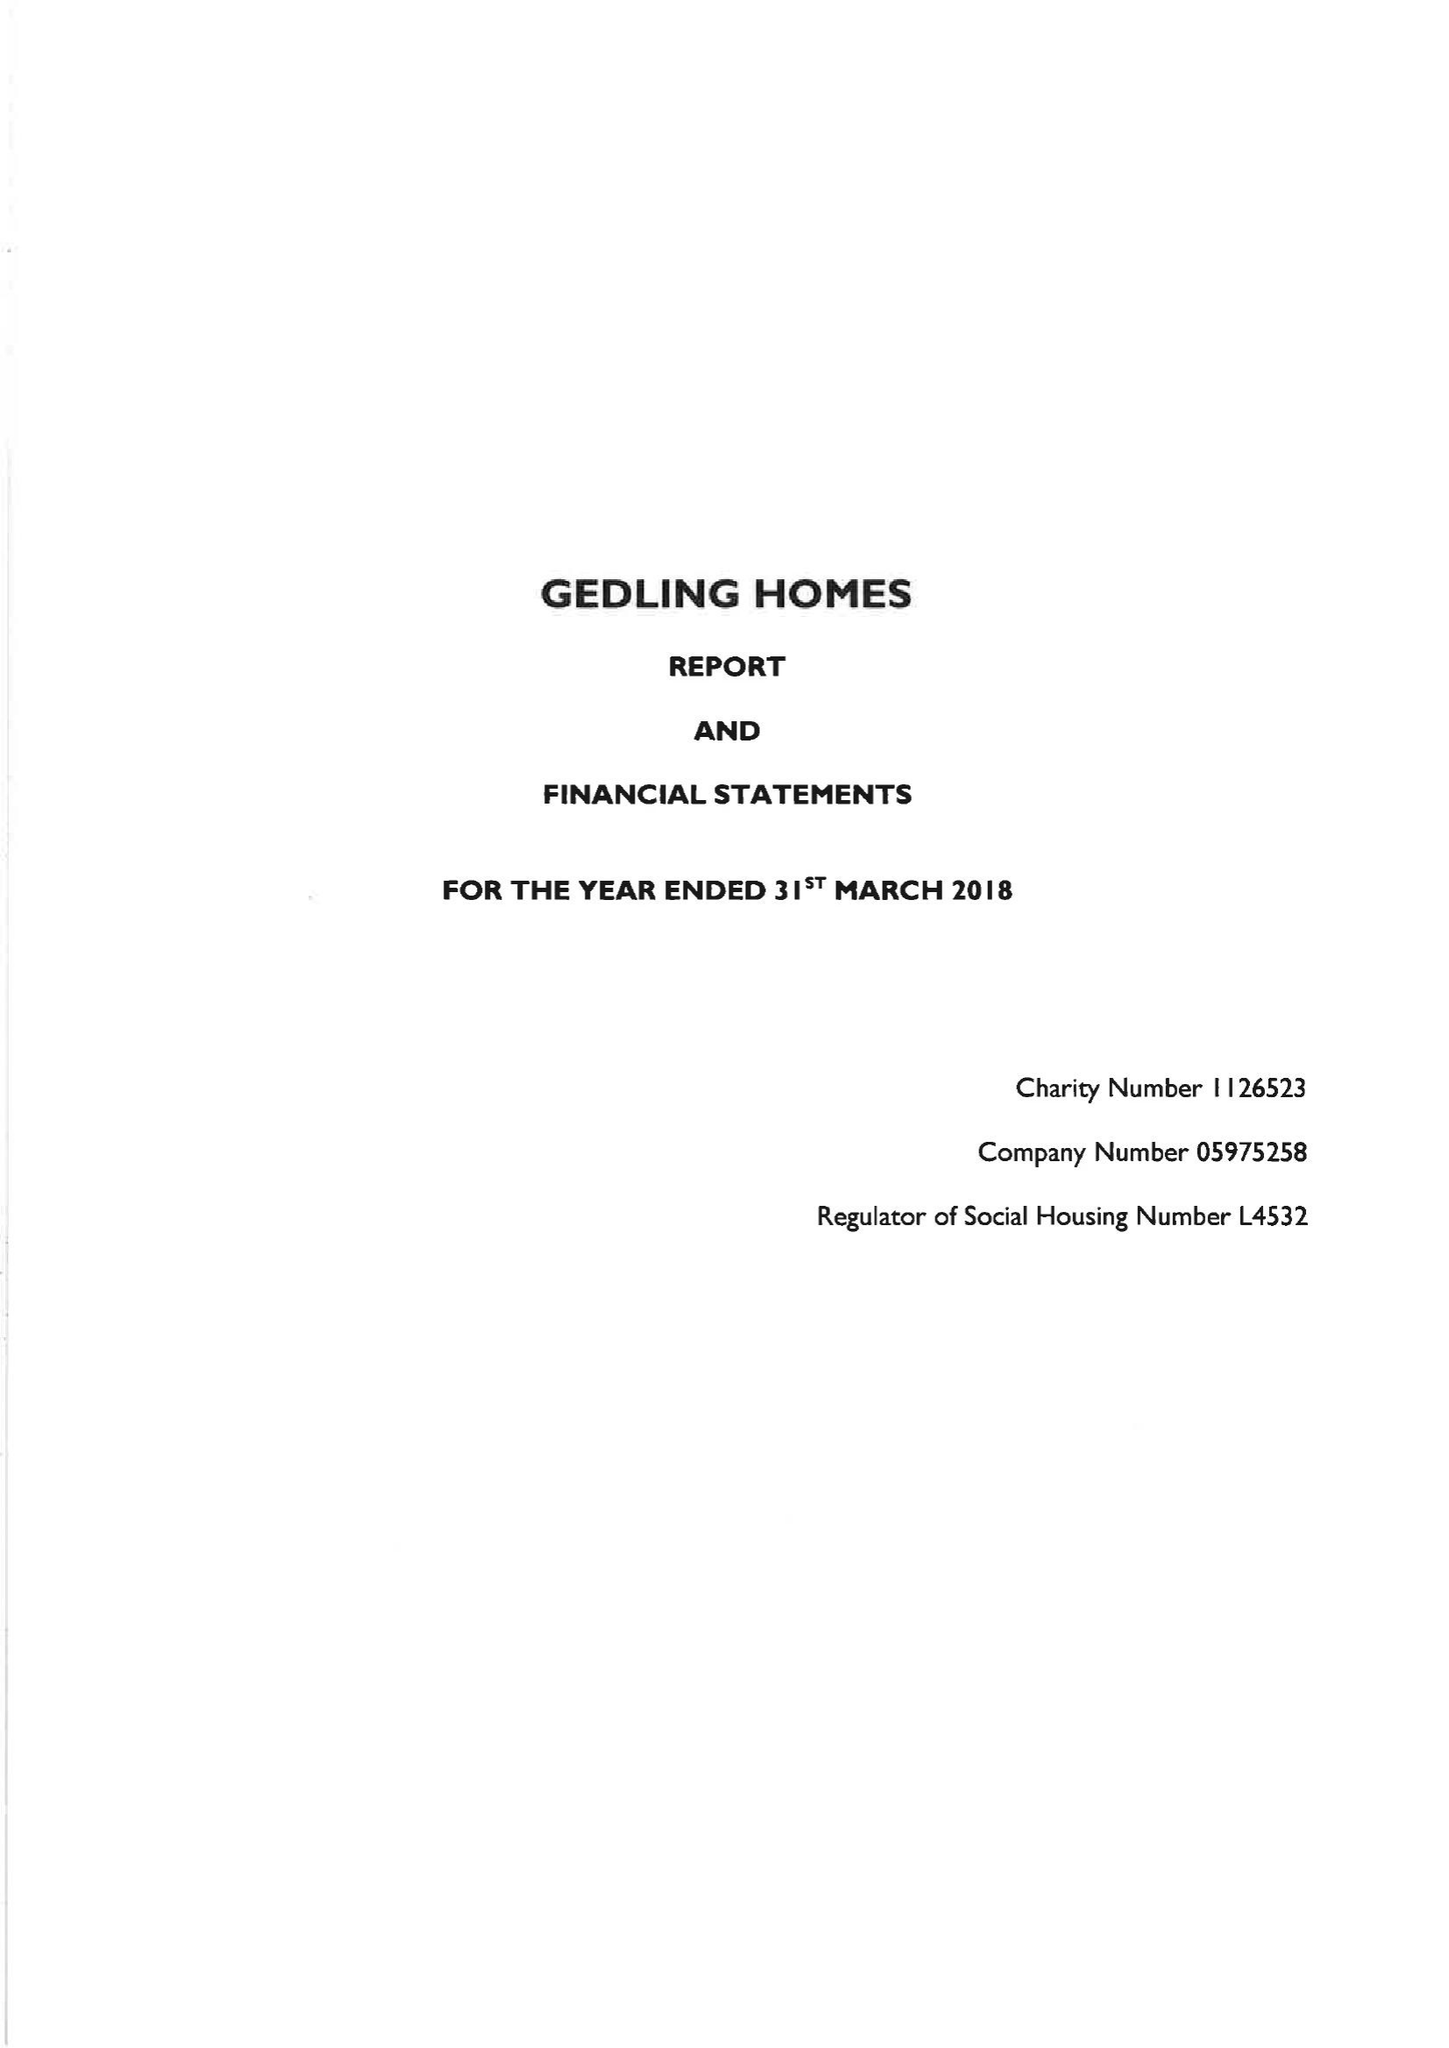What is the value for the charity_name?
Answer the question using a single word or phrase. Gedling Homes Ltd. 